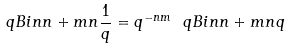Convert formula to latex. <formula><loc_0><loc_0><loc_500><loc_500>\ q B i n { n + m } { n } { \frac { 1 } { q } } = q ^ { - n m } \ q B i n { n + m } { n } { q }</formula> 